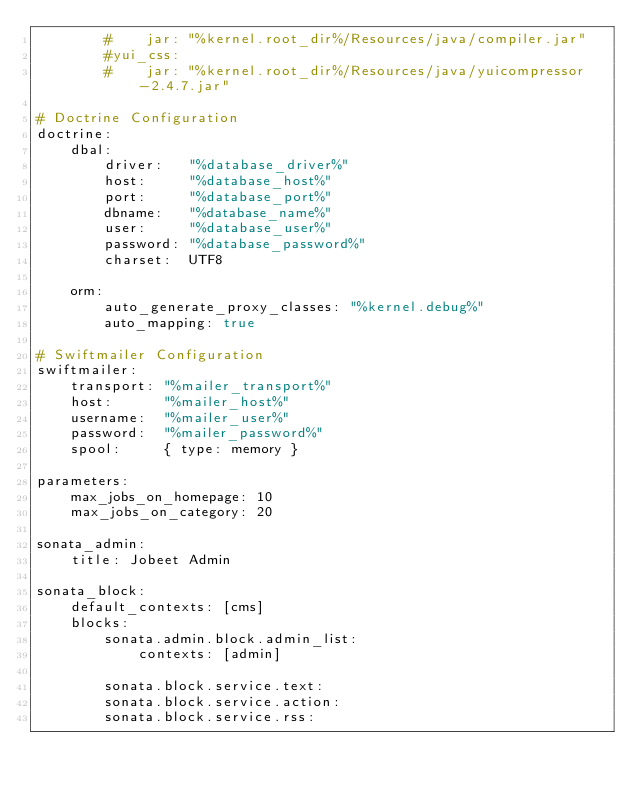<code> <loc_0><loc_0><loc_500><loc_500><_YAML_>        #    jar: "%kernel.root_dir%/Resources/java/compiler.jar"
        #yui_css:
        #    jar: "%kernel.root_dir%/Resources/java/yuicompressor-2.4.7.jar"

# Doctrine Configuration
doctrine:
    dbal:
        driver:   "%database_driver%"
        host:     "%database_host%"
        port:     "%database_port%"
        dbname:   "%database_name%"
        user:     "%database_user%"
        password: "%database_password%"
        charset:  UTF8

    orm:
        auto_generate_proxy_classes: "%kernel.debug%"
        auto_mapping: true

# Swiftmailer Configuration
swiftmailer:
    transport: "%mailer_transport%"
    host:      "%mailer_host%"
    username:  "%mailer_user%"
    password:  "%mailer_password%"
    spool:     { type: memory }

parameters:
    max_jobs_on_homepage: 10
    max_jobs_on_category: 20

sonata_admin:
    title: Jobeet Admin

sonata_block:
    default_contexts: [cms]
    blocks:
        sonata.admin.block.admin_list:
            contexts: [admin]
 
        sonata.block.service.text:
        sonata.block.service.action:
        sonata.block.service.rss:
</code> 